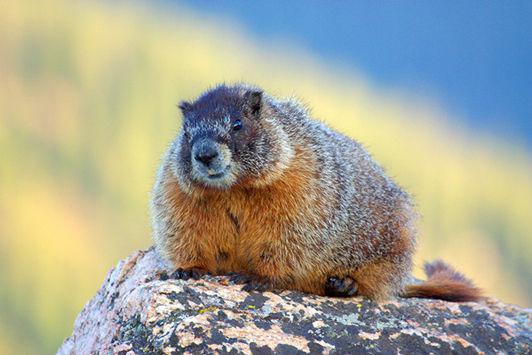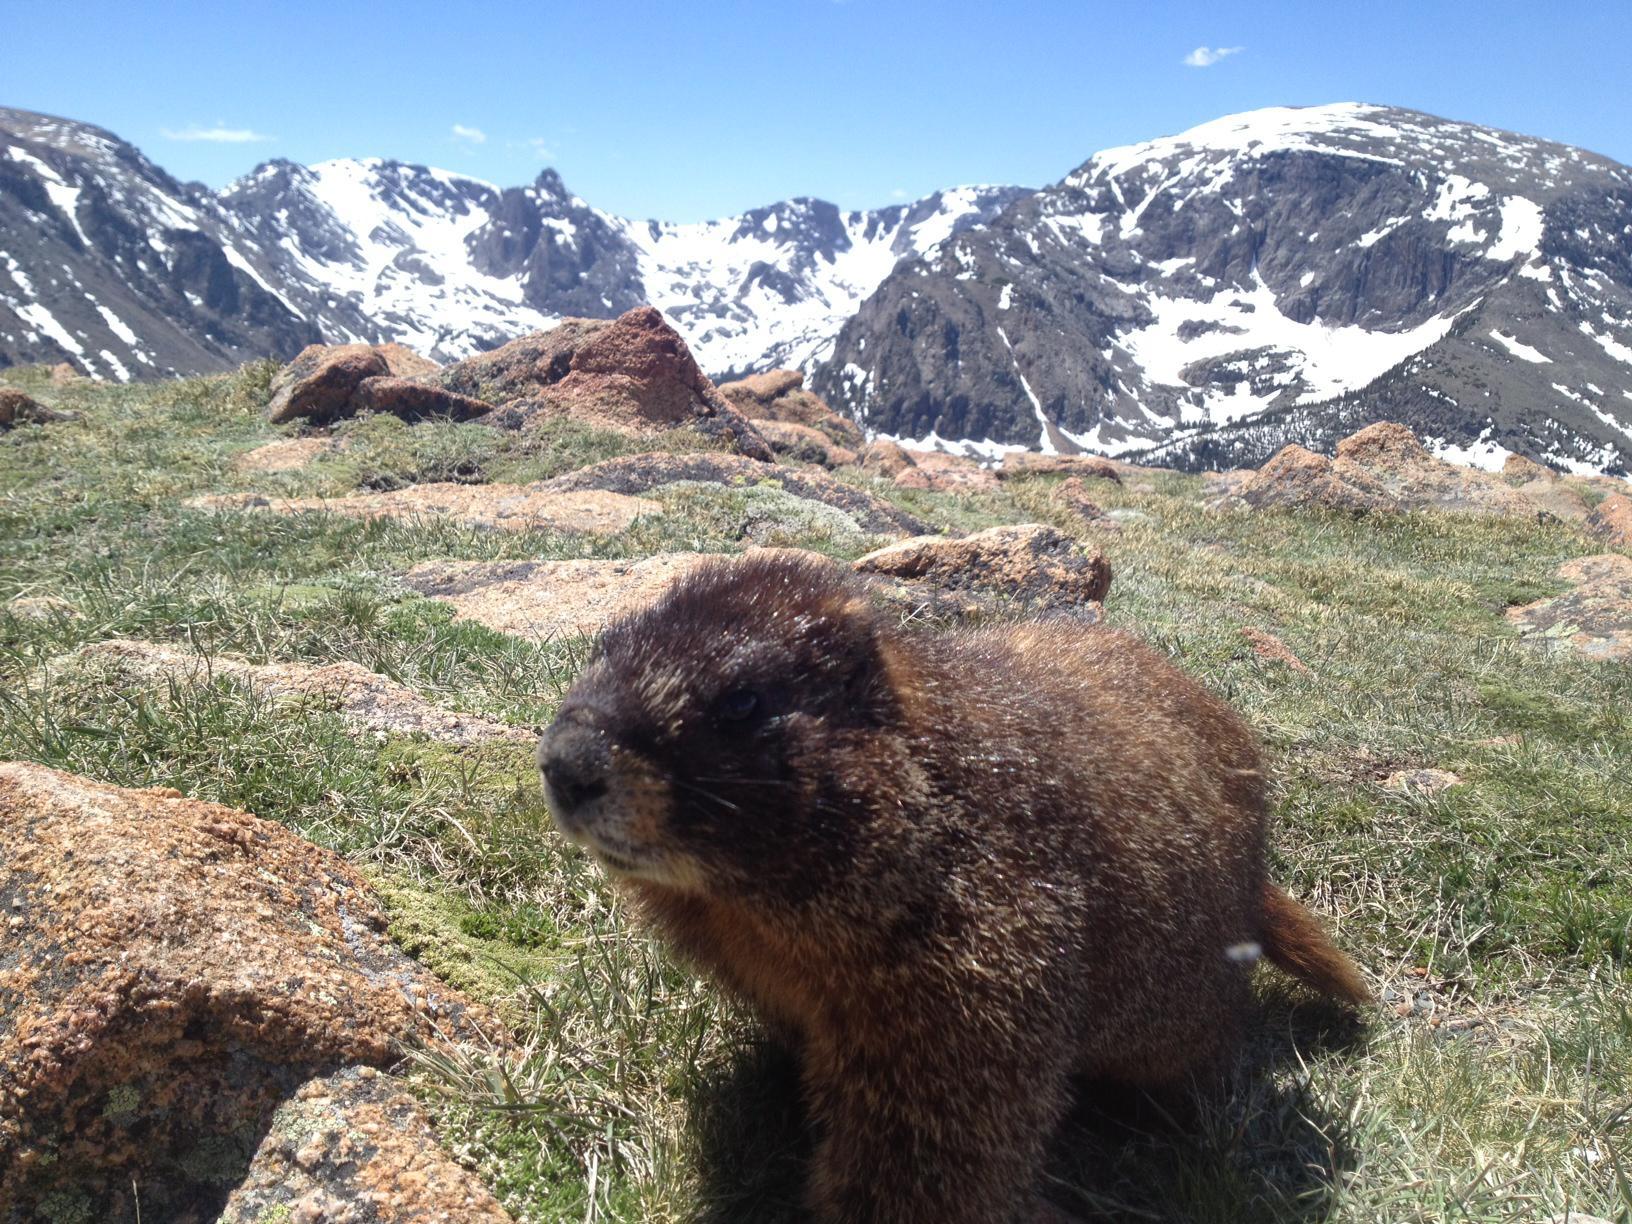The first image is the image on the left, the second image is the image on the right. For the images displayed, is the sentence "A type of rodent is sitting on a rock with both front legs up in the air." factually correct? Answer yes or no. No. The first image is the image on the left, the second image is the image on the right. For the images displayed, is the sentence "An image shows a marmot posed on all fours on a rock, and the image contains only one rock." factually correct? Answer yes or no. Yes. 